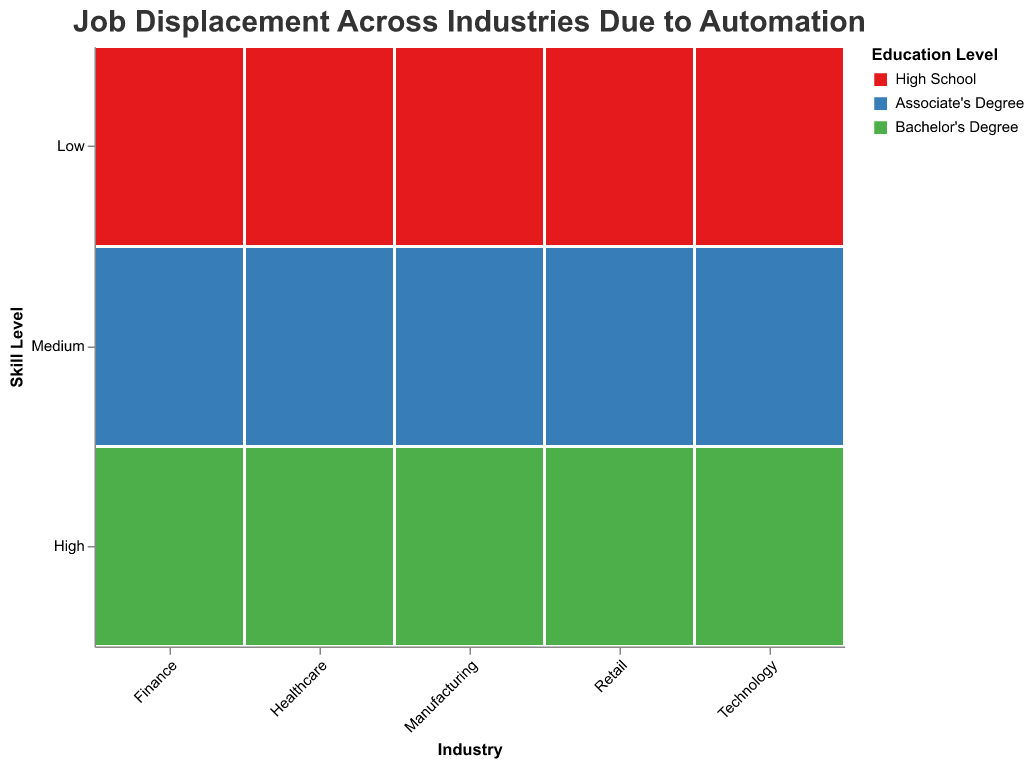What's the title of the graph? The title is displayed prominently at the top and reads "Job Displacement Across Industries Due to Automation".
Answer: Job Displacement Across Industries Due to Automation Which industry has the lowest displacement percentage for high-skill jobs with a Bachelor's degree? By examining the green-colored sections that indicate high-skill jobs with a Bachelor's degree, you can see that Healthcare and Technology both have the smallest sizes, indicating a 5% displacement rate.
Answer: Healthcare and Technology Which industry has the highest displacement percentage for low-skill jobs with a high school education? Look at the red-colored sections representing low-skill jobs with a high school education. Manufacturing has the largest size, indicating a 45% displacement rate.
Answer: Manufacturing In the Retail industry, how does the displacement percentage for medium-skill, Associate's degree compare to high-skill, Bachelor's degree? In the Retail industry, blue represents medium-skill with an Associate's degree (25%), and green represents high-skill with a Bachelor's degree (10%). Thus, medium-skill displacement is 15% higher than high-skill.
Answer: 15% higher Which education level has the smallest displacement percentage in each industry? For each industry, the green-colored sections indicating Bachelor's degree are the smallest across all skill levels, suggesting the lowest displacement percentages.
Answer: Bachelor's degree What is the average displacement percentage for low-skill jobs across all industries? Add the percentages for low-skill jobs in each industry: (45 + 40 + 20 + 35 + 30) = 170. Then divide by the number of industries, which is 5. The average displacement is 170/5 = 34%.
Answer: 34% How do the displacement percentages of Finance and Technology compare for medium-skill, Associate's degree jobs? In both Finance and Technology industries, medium-skill with an Associate's degree is represented in blue. Finance has a displacement percentage of 20%, the same as Technology.
Answer: Equal Which industry shows no displacement percentage exceeding 20% for high-skill, Bachelor’s degree jobs? The green sections representing Bachelor's degree jobs for Healthcare and Technology both have displacement percentages of 5%, which do not exceed 20%.
Answer: Healthcare and Technology What is the total displacement percentage for Manufacturing across all skill levels? Sum the displacement percentages in Manufacturing for each skill level: (45 + 30 + 15) = 90%.
Answer: 90% Which education level has the highest displacement percentage in Retail for low-skill jobs? For low-skill jobs in Retail, which are represented in red, the displacement percentage is 40%, corresponding to high school education.
Answer: High School 